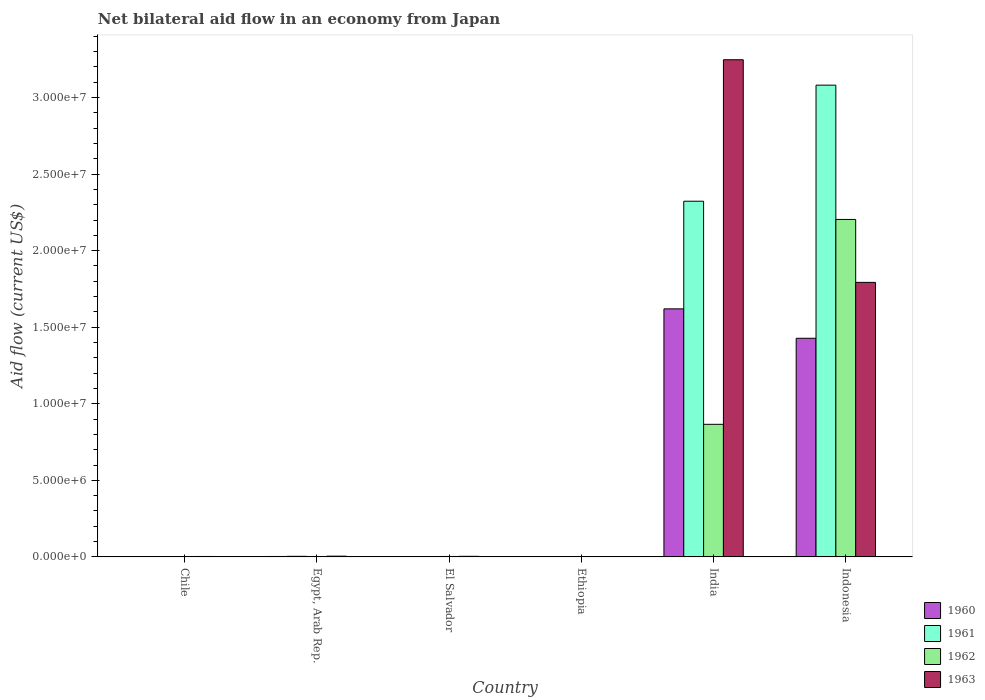Are the number of bars on each tick of the X-axis equal?
Provide a short and direct response. Yes. How many bars are there on the 3rd tick from the left?
Offer a very short reply. 4. How many bars are there on the 3rd tick from the right?
Ensure brevity in your answer.  4. What is the net bilateral aid flow in 1963 in India?
Offer a very short reply. 3.25e+07. Across all countries, what is the maximum net bilateral aid flow in 1960?
Your answer should be compact. 1.62e+07. In which country was the net bilateral aid flow in 1963 minimum?
Your answer should be compact. Ethiopia. What is the total net bilateral aid flow in 1962 in the graph?
Your answer should be very brief. 3.08e+07. What is the difference between the net bilateral aid flow in 1963 in Chile and that in India?
Provide a short and direct response. -3.24e+07. What is the difference between the net bilateral aid flow in 1961 in El Salvador and the net bilateral aid flow in 1960 in Ethiopia?
Give a very brief answer. 0. What is the average net bilateral aid flow in 1963 per country?
Your response must be concise. 8.42e+06. What is the difference between the net bilateral aid flow of/in 1960 and net bilateral aid flow of/in 1961 in El Salvador?
Ensure brevity in your answer.  0. In how many countries, is the net bilateral aid flow in 1962 greater than 26000000 US$?
Make the answer very short. 0. What is the ratio of the net bilateral aid flow in 1963 in Chile to that in Egypt, Arab Rep.?
Provide a short and direct response. 0.6. Is the difference between the net bilateral aid flow in 1960 in Egypt, Arab Rep. and Ethiopia greater than the difference between the net bilateral aid flow in 1961 in Egypt, Arab Rep. and Ethiopia?
Your response must be concise. No. What is the difference between the highest and the second highest net bilateral aid flow in 1961?
Provide a succinct answer. 7.58e+06. What is the difference between the highest and the lowest net bilateral aid flow in 1960?
Make the answer very short. 1.62e+07. In how many countries, is the net bilateral aid flow in 1962 greater than the average net bilateral aid flow in 1962 taken over all countries?
Keep it short and to the point. 2. Is the sum of the net bilateral aid flow in 1960 in Egypt, Arab Rep. and India greater than the maximum net bilateral aid flow in 1963 across all countries?
Provide a succinct answer. No. What does the 3rd bar from the left in India represents?
Ensure brevity in your answer.  1962. What does the 3rd bar from the right in Ethiopia represents?
Your response must be concise. 1961. Are all the bars in the graph horizontal?
Ensure brevity in your answer.  No. How many countries are there in the graph?
Keep it short and to the point. 6. Are the values on the major ticks of Y-axis written in scientific E-notation?
Provide a succinct answer. Yes. Does the graph contain any zero values?
Ensure brevity in your answer.  No. Does the graph contain grids?
Offer a very short reply. No. How many legend labels are there?
Your response must be concise. 4. What is the title of the graph?
Provide a succinct answer. Net bilateral aid flow in an economy from Japan. Does "1989" appear as one of the legend labels in the graph?
Offer a very short reply. No. What is the Aid flow (current US$) of 1962 in Chile?
Provide a succinct answer. 2.00e+04. What is the Aid flow (current US$) in 1963 in Chile?
Offer a terse response. 3.00e+04. What is the Aid flow (current US$) in 1963 in Egypt, Arab Rep.?
Provide a succinct answer. 5.00e+04. What is the Aid flow (current US$) in 1961 in El Salvador?
Offer a terse response. 10000. What is the Aid flow (current US$) in 1962 in El Salvador?
Provide a short and direct response. 3.00e+04. What is the Aid flow (current US$) in 1963 in El Salvador?
Make the answer very short. 4.00e+04. What is the Aid flow (current US$) in 1961 in Ethiopia?
Provide a succinct answer. 10000. What is the Aid flow (current US$) of 1960 in India?
Your answer should be very brief. 1.62e+07. What is the Aid flow (current US$) of 1961 in India?
Keep it short and to the point. 2.32e+07. What is the Aid flow (current US$) in 1962 in India?
Your answer should be compact. 8.66e+06. What is the Aid flow (current US$) of 1963 in India?
Ensure brevity in your answer.  3.25e+07. What is the Aid flow (current US$) of 1960 in Indonesia?
Make the answer very short. 1.43e+07. What is the Aid flow (current US$) of 1961 in Indonesia?
Keep it short and to the point. 3.08e+07. What is the Aid flow (current US$) of 1962 in Indonesia?
Make the answer very short. 2.20e+07. What is the Aid flow (current US$) of 1963 in Indonesia?
Give a very brief answer. 1.79e+07. Across all countries, what is the maximum Aid flow (current US$) of 1960?
Give a very brief answer. 1.62e+07. Across all countries, what is the maximum Aid flow (current US$) of 1961?
Offer a very short reply. 3.08e+07. Across all countries, what is the maximum Aid flow (current US$) of 1962?
Offer a very short reply. 2.20e+07. Across all countries, what is the maximum Aid flow (current US$) in 1963?
Make the answer very short. 3.25e+07. Across all countries, what is the minimum Aid flow (current US$) of 1960?
Offer a very short reply. 10000. Across all countries, what is the minimum Aid flow (current US$) of 1961?
Provide a short and direct response. 10000. Across all countries, what is the minimum Aid flow (current US$) in 1962?
Give a very brief answer. 10000. What is the total Aid flow (current US$) of 1960 in the graph?
Make the answer very short. 3.05e+07. What is the total Aid flow (current US$) of 1961 in the graph?
Your answer should be compact. 5.41e+07. What is the total Aid flow (current US$) of 1962 in the graph?
Give a very brief answer. 3.08e+07. What is the total Aid flow (current US$) of 1963 in the graph?
Keep it short and to the point. 5.05e+07. What is the difference between the Aid flow (current US$) in 1961 in Chile and that in El Salvador?
Offer a very short reply. 0. What is the difference between the Aid flow (current US$) in 1963 in Chile and that in El Salvador?
Provide a short and direct response. -10000. What is the difference between the Aid flow (current US$) of 1961 in Chile and that in Ethiopia?
Keep it short and to the point. 0. What is the difference between the Aid flow (current US$) in 1962 in Chile and that in Ethiopia?
Offer a very short reply. 10000. What is the difference between the Aid flow (current US$) in 1960 in Chile and that in India?
Provide a short and direct response. -1.62e+07. What is the difference between the Aid flow (current US$) in 1961 in Chile and that in India?
Offer a very short reply. -2.32e+07. What is the difference between the Aid flow (current US$) in 1962 in Chile and that in India?
Provide a short and direct response. -8.64e+06. What is the difference between the Aid flow (current US$) in 1963 in Chile and that in India?
Keep it short and to the point. -3.24e+07. What is the difference between the Aid flow (current US$) of 1960 in Chile and that in Indonesia?
Provide a short and direct response. -1.43e+07. What is the difference between the Aid flow (current US$) in 1961 in Chile and that in Indonesia?
Provide a short and direct response. -3.08e+07. What is the difference between the Aid flow (current US$) in 1962 in Chile and that in Indonesia?
Your response must be concise. -2.20e+07. What is the difference between the Aid flow (current US$) in 1963 in Chile and that in Indonesia?
Ensure brevity in your answer.  -1.79e+07. What is the difference between the Aid flow (current US$) in 1961 in Egypt, Arab Rep. and that in El Salvador?
Give a very brief answer. 3.00e+04. What is the difference between the Aid flow (current US$) in 1962 in Egypt, Arab Rep. and that in El Salvador?
Give a very brief answer. 0. What is the difference between the Aid flow (current US$) in 1961 in Egypt, Arab Rep. and that in Ethiopia?
Make the answer very short. 3.00e+04. What is the difference between the Aid flow (current US$) in 1962 in Egypt, Arab Rep. and that in Ethiopia?
Provide a succinct answer. 2.00e+04. What is the difference between the Aid flow (current US$) of 1960 in Egypt, Arab Rep. and that in India?
Your response must be concise. -1.62e+07. What is the difference between the Aid flow (current US$) in 1961 in Egypt, Arab Rep. and that in India?
Your response must be concise. -2.32e+07. What is the difference between the Aid flow (current US$) of 1962 in Egypt, Arab Rep. and that in India?
Your response must be concise. -8.63e+06. What is the difference between the Aid flow (current US$) of 1963 in Egypt, Arab Rep. and that in India?
Your answer should be compact. -3.24e+07. What is the difference between the Aid flow (current US$) of 1960 in Egypt, Arab Rep. and that in Indonesia?
Provide a short and direct response. -1.42e+07. What is the difference between the Aid flow (current US$) of 1961 in Egypt, Arab Rep. and that in Indonesia?
Give a very brief answer. -3.08e+07. What is the difference between the Aid flow (current US$) of 1962 in Egypt, Arab Rep. and that in Indonesia?
Provide a succinct answer. -2.20e+07. What is the difference between the Aid flow (current US$) of 1963 in Egypt, Arab Rep. and that in Indonesia?
Provide a succinct answer. -1.79e+07. What is the difference between the Aid flow (current US$) in 1960 in El Salvador and that in Ethiopia?
Keep it short and to the point. 0. What is the difference between the Aid flow (current US$) in 1962 in El Salvador and that in Ethiopia?
Offer a terse response. 2.00e+04. What is the difference between the Aid flow (current US$) of 1960 in El Salvador and that in India?
Your answer should be very brief. -1.62e+07. What is the difference between the Aid flow (current US$) of 1961 in El Salvador and that in India?
Your answer should be compact. -2.32e+07. What is the difference between the Aid flow (current US$) of 1962 in El Salvador and that in India?
Offer a very short reply. -8.63e+06. What is the difference between the Aid flow (current US$) of 1963 in El Salvador and that in India?
Ensure brevity in your answer.  -3.24e+07. What is the difference between the Aid flow (current US$) in 1960 in El Salvador and that in Indonesia?
Your answer should be very brief. -1.43e+07. What is the difference between the Aid flow (current US$) in 1961 in El Salvador and that in Indonesia?
Ensure brevity in your answer.  -3.08e+07. What is the difference between the Aid flow (current US$) in 1962 in El Salvador and that in Indonesia?
Give a very brief answer. -2.20e+07. What is the difference between the Aid flow (current US$) of 1963 in El Salvador and that in Indonesia?
Your answer should be very brief. -1.79e+07. What is the difference between the Aid flow (current US$) in 1960 in Ethiopia and that in India?
Make the answer very short. -1.62e+07. What is the difference between the Aid flow (current US$) in 1961 in Ethiopia and that in India?
Your answer should be very brief. -2.32e+07. What is the difference between the Aid flow (current US$) of 1962 in Ethiopia and that in India?
Provide a succinct answer. -8.65e+06. What is the difference between the Aid flow (current US$) in 1963 in Ethiopia and that in India?
Provide a succinct answer. -3.25e+07. What is the difference between the Aid flow (current US$) in 1960 in Ethiopia and that in Indonesia?
Ensure brevity in your answer.  -1.43e+07. What is the difference between the Aid flow (current US$) in 1961 in Ethiopia and that in Indonesia?
Offer a terse response. -3.08e+07. What is the difference between the Aid flow (current US$) of 1962 in Ethiopia and that in Indonesia?
Provide a succinct answer. -2.20e+07. What is the difference between the Aid flow (current US$) of 1963 in Ethiopia and that in Indonesia?
Your response must be concise. -1.79e+07. What is the difference between the Aid flow (current US$) in 1960 in India and that in Indonesia?
Offer a terse response. 1.92e+06. What is the difference between the Aid flow (current US$) of 1961 in India and that in Indonesia?
Your answer should be compact. -7.58e+06. What is the difference between the Aid flow (current US$) of 1962 in India and that in Indonesia?
Your answer should be very brief. -1.34e+07. What is the difference between the Aid flow (current US$) in 1963 in India and that in Indonesia?
Provide a succinct answer. 1.45e+07. What is the difference between the Aid flow (current US$) of 1960 in Chile and the Aid flow (current US$) of 1963 in Egypt, Arab Rep.?
Ensure brevity in your answer.  -4.00e+04. What is the difference between the Aid flow (current US$) of 1961 in Chile and the Aid flow (current US$) of 1962 in Egypt, Arab Rep.?
Provide a succinct answer. -2.00e+04. What is the difference between the Aid flow (current US$) of 1960 in Chile and the Aid flow (current US$) of 1961 in El Salvador?
Ensure brevity in your answer.  0. What is the difference between the Aid flow (current US$) in 1961 in Chile and the Aid flow (current US$) in 1962 in El Salvador?
Offer a terse response. -2.00e+04. What is the difference between the Aid flow (current US$) of 1961 in Chile and the Aid flow (current US$) of 1963 in El Salvador?
Ensure brevity in your answer.  -3.00e+04. What is the difference between the Aid flow (current US$) of 1962 in Chile and the Aid flow (current US$) of 1963 in Ethiopia?
Provide a short and direct response. 10000. What is the difference between the Aid flow (current US$) in 1960 in Chile and the Aid flow (current US$) in 1961 in India?
Make the answer very short. -2.32e+07. What is the difference between the Aid flow (current US$) of 1960 in Chile and the Aid flow (current US$) of 1962 in India?
Offer a terse response. -8.65e+06. What is the difference between the Aid flow (current US$) in 1960 in Chile and the Aid flow (current US$) in 1963 in India?
Keep it short and to the point. -3.25e+07. What is the difference between the Aid flow (current US$) in 1961 in Chile and the Aid flow (current US$) in 1962 in India?
Your response must be concise. -8.65e+06. What is the difference between the Aid flow (current US$) of 1961 in Chile and the Aid flow (current US$) of 1963 in India?
Keep it short and to the point. -3.25e+07. What is the difference between the Aid flow (current US$) of 1962 in Chile and the Aid flow (current US$) of 1963 in India?
Provide a succinct answer. -3.24e+07. What is the difference between the Aid flow (current US$) of 1960 in Chile and the Aid flow (current US$) of 1961 in Indonesia?
Offer a very short reply. -3.08e+07. What is the difference between the Aid flow (current US$) in 1960 in Chile and the Aid flow (current US$) in 1962 in Indonesia?
Give a very brief answer. -2.20e+07. What is the difference between the Aid flow (current US$) in 1960 in Chile and the Aid flow (current US$) in 1963 in Indonesia?
Your response must be concise. -1.79e+07. What is the difference between the Aid flow (current US$) of 1961 in Chile and the Aid flow (current US$) of 1962 in Indonesia?
Your response must be concise. -2.20e+07. What is the difference between the Aid flow (current US$) in 1961 in Chile and the Aid flow (current US$) in 1963 in Indonesia?
Your answer should be compact. -1.79e+07. What is the difference between the Aid flow (current US$) in 1962 in Chile and the Aid flow (current US$) in 1963 in Indonesia?
Your answer should be very brief. -1.79e+07. What is the difference between the Aid flow (current US$) of 1960 in Egypt, Arab Rep. and the Aid flow (current US$) of 1961 in El Salvador?
Your answer should be compact. 2.00e+04. What is the difference between the Aid flow (current US$) of 1960 in Egypt, Arab Rep. and the Aid flow (current US$) of 1962 in El Salvador?
Ensure brevity in your answer.  0. What is the difference between the Aid flow (current US$) in 1961 in Egypt, Arab Rep. and the Aid flow (current US$) in 1962 in El Salvador?
Your response must be concise. 10000. What is the difference between the Aid flow (current US$) of 1962 in Egypt, Arab Rep. and the Aid flow (current US$) of 1963 in El Salvador?
Give a very brief answer. -10000. What is the difference between the Aid flow (current US$) of 1960 in Egypt, Arab Rep. and the Aid flow (current US$) of 1961 in Ethiopia?
Make the answer very short. 2.00e+04. What is the difference between the Aid flow (current US$) of 1960 in Egypt, Arab Rep. and the Aid flow (current US$) of 1962 in Ethiopia?
Keep it short and to the point. 2.00e+04. What is the difference between the Aid flow (current US$) of 1960 in Egypt, Arab Rep. and the Aid flow (current US$) of 1963 in Ethiopia?
Make the answer very short. 2.00e+04. What is the difference between the Aid flow (current US$) in 1961 in Egypt, Arab Rep. and the Aid flow (current US$) in 1962 in Ethiopia?
Offer a very short reply. 3.00e+04. What is the difference between the Aid flow (current US$) of 1961 in Egypt, Arab Rep. and the Aid flow (current US$) of 1963 in Ethiopia?
Your answer should be very brief. 3.00e+04. What is the difference between the Aid flow (current US$) of 1960 in Egypt, Arab Rep. and the Aid flow (current US$) of 1961 in India?
Offer a very short reply. -2.32e+07. What is the difference between the Aid flow (current US$) in 1960 in Egypt, Arab Rep. and the Aid flow (current US$) in 1962 in India?
Your answer should be compact. -8.63e+06. What is the difference between the Aid flow (current US$) of 1960 in Egypt, Arab Rep. and the Aid flow (current US$) of 1963 in India?
Make the answer very short. -3.24e+07. What is the difference between the Aid flow (current US$) in 1961 in Egypt, Arab Rep. and the Aid flow (current US$) in 1962 in India?
Provide a short and direct response. -8.62e+06. What is the difference between the Aid flow (current US$) of 1961 in Egypt, Arab Rep. and the Aid flow (current US$) of 1963 in India?
Provide a short and direct response. -3.24e+07. What is the difference between the Aid flow (current US$) of 1962 in Egypt, Arab Rep. and the Aid flow (current US$) of 1963 in India?
Offer a terse response. -3.24e+07. What is the difference between the Aid flow (current US$) in 1960 in Egypt, Arab Rep. and the Aid flow (current US$) in 1961 in Indonesia?
Offer a terse response. -3.08e+07. What is the difference between the Aid flow (current US$) in 1960 in Egypt, Arab Rep. and the Aid flow (current US$) in 1962 in Indonesia?
Your response must be concise. -2.20e+07. What is the difference between the Aid flow (current US$) of 1960 in Egypt, Arab Rep. and the Aid flow (current US$) of 1963 in Indonesia?
Offer a terse response. -1.79e+07. What is the difference between the Aid flow (current US$) in 1961 in Egypt, Arab Rep. and the Aid flow (current US$) in 1962 in Indonesia?
Give a very brief answer. -2.20e+07. What is the difference between the Aid flow (current US$) in 1961 in Egypt, Arab Rep. and the Aid flow (current US$) in 1963 in Indonesia?
Keep it short and to the point. -1.79e+07. What is the difference between the Aid flow (current US$) in 1962 in Egypt, Arab Rep. and the Aid flow (current US$) in 1963 in Indonesia?
Provide a short and direct response. -1.79e+07. What is the difference between the Aid flow (current US$) of 1960 in El Salvador and the Aid flow (current US$) of 1962 in Ethiopia?
Give a very brief answer. 0. What is the difference between the Aid flow (current US$) in 1961 in El Salvador and the Aid flow (current US$) in 1962 in Ethiopia?
Provide a short and direct response. 0. What is the difference between the Aid flow (current US$) of 1962 in El Salvador and the Aid flow (current US$) of 1963 in Ethiopia?
Your response must be concise. 2.00e+04. What is the difference between the Aid flow (current US$) of 1960 in El Salvador and the Aid flow (current US$) of 1961 in India?
Your response must be concise. -2.32e+07. What is the difference between the Aid flow (current US$) of 1960 in El Salvador and the Aid flow (current US$) of 1962 in India?
Your response must be concise. -8.65e+06. What is the difference between the Aid flow (current US$) in 1960 in El Salvador and the Aid flow (current US$) in 1963 in India?
Your answer should be compact. -3.25e+07. What is the difference between the Aid flow (current US$) of 1961 in El Salvador and the Aid flow (current US$) of 1962 in India?
Give a very brief answer. -8.65e+06. What is the difference between the Aid flow (current US$) in 1961 in El Salvador and the Aid flow (current US$) in 1963 in India?
Your response must be concise. -3.25e+07. What is the difference between the Aid flow (current US$) of 1962 in El Salvador and the Aid flow (current US$) of 1963 in India?
Give a very brief answer. -3.24e+07. What is the difference between the Aid flow (current US$) of 1960 in El Salvador and the Aid flow (current US$) of 1961 in Indonesia?
Your answer should be compact. -3.08e+07. What is the difference between the Aid flow (current US$) in 1960 in El Salvador and the Aid flow (current US$) in 1962 in Indonesia?
Keep it short and to the point. -2.20e+07. What is the difference between the Aid flow (current US$) of 1960 in El Salvador and the Aid flow (current US$) of 1963 in Indonesia?
Your response must be concise. -1.79e+07. What is the difference between the Aid flow (current US$) in 1961 in El Salvador and the Aid flow (current US$) in 1962 in Indonesia?
Keep it short and to the point. -2.20e+07. What is the difference between the Aid flow (current US$) in 1961 in El Salvador and the Aid flow (current US$) in 1963 in Indonesia?
Provide a short and direct response. -1.79e+07. What is the difference between the Aid flow (current US$) in 1962 in El Salvador and the Aid flow (current US$) in 1963 in Indonesia?
Your answer should be compact. -1.79e+07. What is the difference between the Aid flow (current US$) of 1960 in Ethiopia and the Aid flow (current US$) of 1961 in India?
Offer a very short reply. -2.32e+07. What is the difference between the Aid flow (current US$) of 1960 in Ethiopia and the Aid flow (current US$) of 1962 in India?
Provide a short and direct response. -8.65e+06. What is the difference between the Aid flow (current US$) of 1960 in Ethiopia and the Aid flow (current US$) of 1963 in India?
Provide a succinct answer. -3.25e+07. What is the difference between the Aid flow (current US$) in 1961 in Ethiopia and the Aid flow (current US$) in 1962 in India?
Your answer should be compact. -8.65e+06. What is the difference between the Aid flow (current US$) in 1961 in Ethiopia and the Aid flow (current US$) in 1963 in India?
Provide a short and direct response. -3.25e+07. What is the difference between the Aid flow (current US$) of 1962 in Ethiopia and the Aid flow (current US$) of 1963 in India?
Your response must be concise. -3.25e+07. What is the difference between the Aid flow (current US$) of 1960 in Ethiopia and the Aid flow (current US$) of 1961 in Indonesia?
Your answer should be compact. -3.08e+07. What is the difference between the Aid flow (current US$) of 1960 in Ethiopia and the Aid flow (current US$) of 1962 in Indonesia?
Your answer should be very brief. -2.20e+07. What is the difference between the Aid flow (current US$) in 1960 in Ethiopia and the Aid flow (current US$) in 1963 in Indonesia?
Your response must be concise. -1.79e+07. What is the difference between the Aid flow (current US$) of 1961 in Ethiopia and the Aid flow (current US$) of 1962 in Indonesia?
Keep it short and to the point. -2.20e+07. What is the difference between the Aid flow (current US$) in 1961 in Ethiopia and the Aid flow (current US$) in 1963 in Indonesia?
Offer a very short reply. -1.79e+07. What is the difference between the Aid flow (current US$) in 1962 in Ethiopia and the Aid flow (current US$) in 1963 in Indonesia?
Offer a terse response. -1.79e+07. What is the difference between the Aid flow (current US$) of 1960 in India and the Aid flow (current US$) of 1961 in Indonesia?
Your answer should be compact. -1.46e+07. What is the difference between the Aid flow (current US$) of 1960 in India and the Aid flow (current US$) of 1962 in Indonesia?
Your response must be concise. -5.84e+06. What is the difference between the Aid flow (current US$) in 1960 in India and the Aid flow (current US$) in 1963 in Indonesia?
Provide a short and direct response. -1.73e+06. What is the difference between the Aid flow (current US$) in 1961 in India and the Aid flow (current US$) in 1962 in Indonesia?
Ensure brevity in your answer.  1.19e+06. What is the difference between the Aid flow (current US$) in 1961 in India and the Aid flow (current US$) in 1963 in Indonesia?
Offer a terse response. 5.30e+06. What is the difference between the Aid flow (current US$) in 1962 in India and the Aid flow (current US$) in 1963 in Indonesia?
Keep it short and to the point. -9.27e+06. What is the average Aid flow (current US$) in 1960 per country?
Make the answer very short. 5.09e+06. What is the average Aid flow (current US$) of 1961 per country?
Provide a succinct answer. 9.02e+06. What is the average Aid flow (current US$) in 1962 per country?
Keep it short and to the point. 5.13e+06. What is the average Aid flow (current US$) in 1963 per country?
Ensure brevity in your answer.  8.42e+06. What is the difference between the Aid flow (current US$) in 1960 and Aid flow (current US$) in 1961 in Chile?
Ensure brevity in your answer.  0. What is the difference between the Aid flow (current US$) in 1960 and Aid flow (current US$) in 1963 in Chile?
Make the answer very short. -2.00e+04. What is the difference between the Aid flow (current US$) of 1961 and Aid flow (current US$) of 1963 in Chile?
Your response must be concise. -2.00e+04. What is the difference between the Aid flow (current US$) in 1962 and Aid flow (current US$) in 1963 in Chile?
Provide a succinct answer. -10000. What is the difference between the Aid flow (current US$) in 1960 and Aid flow (current US$) in 1961 in Egypt, Arab Rep.?
Offer a very short reply. -10000. What is the difference between the Aid flow (current US$) in 1961 and Aid flow (current US$) in 1963 in Egypt, Arab Rep.?
Ensure brevity in your answer.  -10000. What is the difference between the Aid flow (current US$) of 1960 and Aid flow (current US$) of 1963 in El Salvador?
Keep it short and to the point. -3.00e+04. What is the difference between the Aid flow (current US$) of 1961 and Aid flow (current US$) of 1962 in El Salvador?
Offer a very short reply. -2.00e+04. What is the difference between the Aid flow (current US$) of 1961 and Aid flow (current US$) of 1963 in El Salvador?
Make the answer very short. -3.00e+04. What is the difference between the Aid flow (current US$) in 1960 and Aid flow (current US$) in 1963 in Ethiopia?
Offer a very short reply. 0. What is the difference between the Aid flow (current US$) of 1961 and Aid flow (current US$) of 1963 in Ethiopia?
Provide a succinct answer. 0. What is the difference between the Aid flow (current US$) of 1960 and Aid flow (current US$) of 1961 in India?
Keep it short and to the point. -7.03e+06. What is the difference between the Aid flow (current US$) of 1960 and Aid flow (current US$) of 1962 in India?
Make the answer very short. 7.54e+06. What is the difference between the Aid flow (current US$) in 1960 and Aid flow (current US$) in 1963 in India?
Your response must be concise. -1.63e+07. What is the difference between the Aid flow (current US$) in 1961 and Aid flow (current US$) in 1962 in India?
Ensure brevity in your answer.  1.46e+07. What is the difference between the Aid flow (current US$) in 1961 and Aid flow (current US$) in 1963 in India?
Keep it short and to the point. -9.24e+06. What is the difference between the Aid flow (current US$) in 1962 and Aid flow (current US$) in 1963 in India?
Your response must be concise. -2.38e+07. What is the difference between the Aid flow (current US$) in 1960 and Aid flow (current US$) in 1961 in Indonesia?
Keep it short and to the point. -1.65e+07. What is the difference between the Aid flow (current US$) in 1960 and Aid flow (current US$) in 1962 in Indonesia?
Ensure brevity in your answer.  -7.76e+06. What is the difference between the Aid flow (current US$) of 1960 and Aid flow (current US$) of 1963 in Indonesia?
Provide a short and direct response. -3.65e+06. What is the difference between the Aid flow (current US$) of 1961 and Aid flow (current US$) of 1962 in Indonesia?
Your answer should be compact. 8.77e+06. What is the difference between the Aid flow (current US$) in 1961 and Aid flow (current US$) in 1963 in Indonesia?
Provide a succinct answer. 1.29e+07. What is the difference between the Aid flow (current US$) of 1962 and Aid flow (current US$) of 1963 in Indonesia?
Offer a terse response. 4.11e+06. What is the ratio of the Aid flow (current US$) of 1962 in Chile to that in Egypt, Arab Rep.?
Make the answer very short. 0.67. What is the ratio of the Aid flow (current US$) in 1963 in Chile to that in Egypt, Arab Rep.?
Offer a very short reply. 0.6. What is the ratio of the Aid flow (current US$) of 1960 in Chile to that in El Salvador?
Your response must be concise. 1. What is the ratio of the Aid flow (current US$) in 1963 in Chile to that in El Salvador?
Your response must be concise. 0.75. What is the ratio of the Aid flow (current US$) of 1961 in Chile to that in Ethiopia?
Provide a succinct answer. 1. What is the ratio of the Aid flow (current US$) of 1963 in Chile to that in Ethiopia?
Your answer should be very brief. 3. What is the ratio of the Aid flow (current US$) in 1960 in Chile to that in India?
Your response must be concise. 0. What is the ratio of the Aid flow (current US$) of 1961 in Chile to that in India?
Provide a succinct answer. 0. What is the ratio of the Aid flow (current US$) of 1962 in Chile to that in India?
Provide a short and direct response. 0. What is the ratio of the Aid flow (current US$) in 1963 in Chile to that in India?
Give a very brief answer. 0. What is the ratio of the Aid flow (current US$) of 1960 in Chile to that in Indonesia?
Give a very brief answer. 0. What is the ratio of the Aid flow (current US$) in 1962 in Chile to that in Indonesia?
Make the answer very short. 0. What is the ratio of the Aid flow (current US$) in 1963 in Chile to that in Indonesia?
Keep it short and to the point. 0. What is the ratio of the Aid flow (current US$) of 1960 in Egypt, Arab Rep. to that in El Salvador?
Your answer should be compact. 3. What is the ratio of the Aid flow (current US$) of 1963 in Egypt, Arab Rep. to that in El Salvador?
Provide a short and direct response. 1.25. What is the ratio of the Aid flow (current US$) in 1960 in Egypt, Arab Rep. to that in Ethiopia?
Provide a short and direct response. 3. What is the ratio of the Aid flow (current US$) in 1961 in Egypt, Arab Rep. to that in Ethiopia?
Your answer should be compact. 4. What is the ratio of the Aid flow (current US$) in 1963 in Egypt, Arab Rep. to that in Ethiopia?
Your answer should be very brief. 5. What is the ratio of the Aid flow (current US$) in 1960 in Egypt, Arab Rep. to that in India?
Ensure brevity in your answer.  0. What is the ratio of the Aid flow (current US$) of 1961 in Egypt, Arab Rep. to that in India?
Give a very brief answer. 0. What is the ratio of the Aid flow (current US$) in 1962 in Egypt, Arab Rep. to that in India?
Offer a terse response. 0. What is the ratio of the Aid flow (current US$) in 1963 in Egypt, Arab Rep. to that in India?
Ensure brevity in your answer.  0. What is the ratio of the Aid flow (current US$) of 1960 in Egypt, Arab Rep. to that in Indonesia?
Provide a short and direct response. 0. What is the ratio of the Aid flow (current US$) of 1961 in Egypt, Arab Rep. to that in Indonesia?
Ensure brevity in your answer.  0. What is the ratio of the Aid flow (current US$) of 1962 in Egypt, Arab Rep. to that in Indonesia?
Make the answer very short. 0. What is the ratio of the Aid flow (current US$) in 1963 in Egypt, Arab Rep. to that in Indonesia?
Your response must be concise. 0. What is the ratio of the Aid flow (current US$) of 1962 in El Salvador to that in Ethiopia?
Ensure brevity in your answer.  3. What is the ratio of the Aid flow (current US$) in 1960 in El Salvador to that in India?
Your answer should be very brief. 0. What is the ratio of the Aid flow (current US$) of 1962 in El Salvador to that in India?
Make the answer very short. 0. What is the ratio of the Aid flow (current US$) in 1963 in El Salvador to that in India?
Your answer should be compact. 0. What is the ratio of the Aid flow (current US$) in 1960 in El Salvador to that in Indonesia?
Your answer should be compact. 0. What is the ratio of the Aid flow (current US$) of 1962 in El Salvador to that in Indonesia?
Offer a terse response. 0. What is the ratio of the Aid flow (current US$) in 1963 in El Salvador to that in Indonesia?
Your answer should be compact. 0. What is the ratio of the Aid flow (current US$) in 1960 in Ethiopia to that in India?
Your answer should be very brief. 0. What is the ratio of the Aid flow (current US$) of 1961 in Ethiopia to that in India?
Keep it short and to the point. 0. What is the ratio of the Aid flow (current US$) of 1962 in Ethiopia to that in India?
Your response must be concise. 0. What is the ratio of the Aid flow (current US$) of 1963 in Ethiopia to that in India?
Offer a terse response. 0. What is the ratio of the Aid flow (current US$) in 1960 in Ethiopia to that in Indonesia?
Make the answer very short. 0. What is the ratio of the Aid flow (current US$) in 1962 in Ethiopia to that in Indonesia?
Keep it short and to the point. 0. What is the ratio of the Aid flow (current US$) of 1963 in Ethiopia to that in Indonesia?
Your response must be concise. 0. What is the ratio of the Aid flow (current US$) in 1960 in India to that in Indonesia?
Ensure brevity in your answer.  1.13. What is the ratio of the Aid flow (current US$) of 1961 in India to that in Indonesia?
Offer a terse response. 0.75. What is the ratio of the Aid flow (current US$) of 1962 in India to that in Indonesia?
Offer a very short reply. 0.39. What is the ratio of the Aid flow (current US$) in 1963 in India to that in Indonesia?
Provide a succinct answer. 1.81. What is the difference between the highest and the second highest Aid flow (current US$) of 1960?
Provide a short and direct response. 1.92e+06. What is the difference between the highest and the second highest Aid flow (current US$) of 1961?
Ensure brevity in your answer.  7.58e+06. What is the difference between the highest and the second highest Aid flow (current US$) of 1962?
Your answer should be very brief. 1.34e+07. What is the difference between the highest and the second highest Aid flow (current US$) of 1963?
Provide a succinct answer. 1.45e+07. What is the difference between the highest and the lowest Aid flow (current US$) in 1960?
Provide a short and direct response. 1.62e+07. What is the difference between the highest and the lowest Aid flow (current US$) of 1961?
Provide a succinct answer. 3.08e+07. What is the difference between the highest and the lowest Aid flow (current US$) in 1962?
Ensure brevity in your answer.  2.20e+07. What is the difference between the highest and the lowest Aid flow (current US$) in 1963?
Your answer should be very brief. 3.25e+07. 